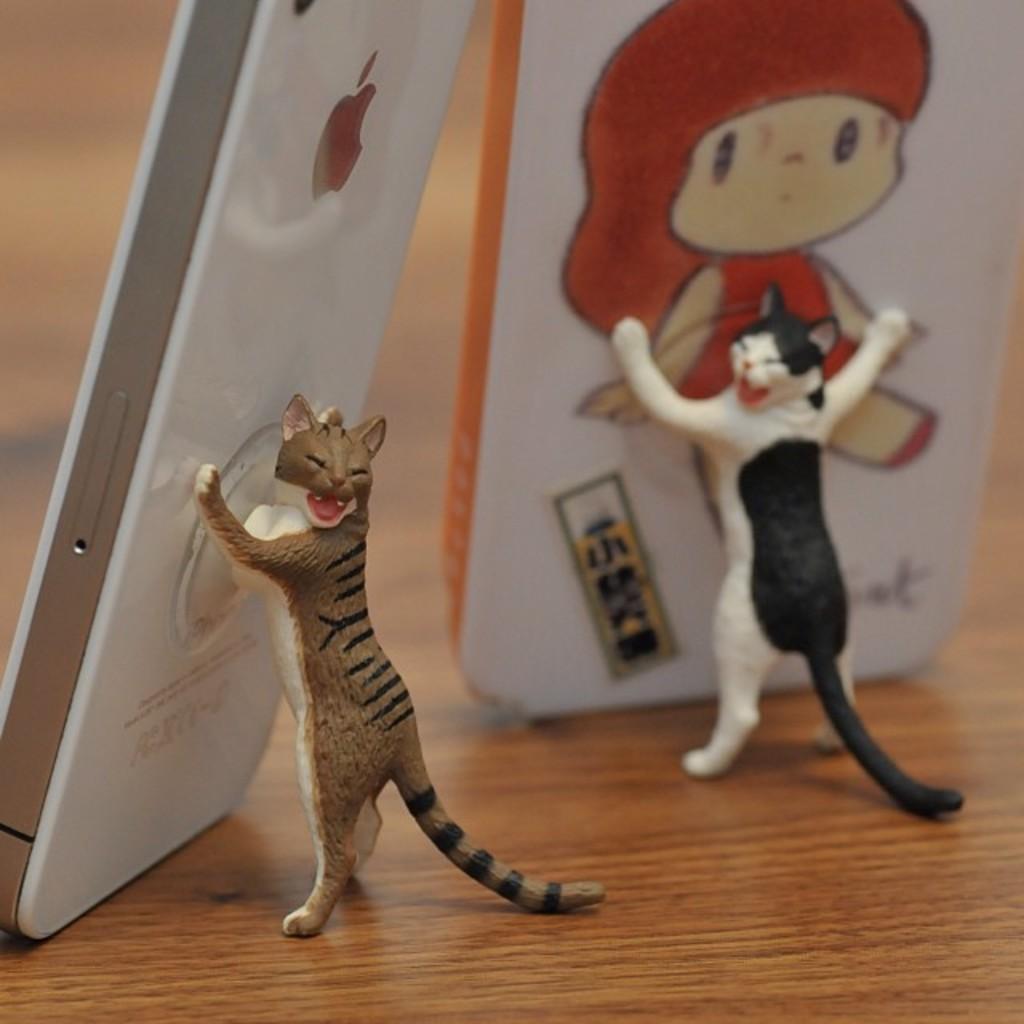How would you summarize this image in a sentence or two? In this image we can see mobiles with mobile stands in cat structure. In the background of the image there is a wooden texture. 